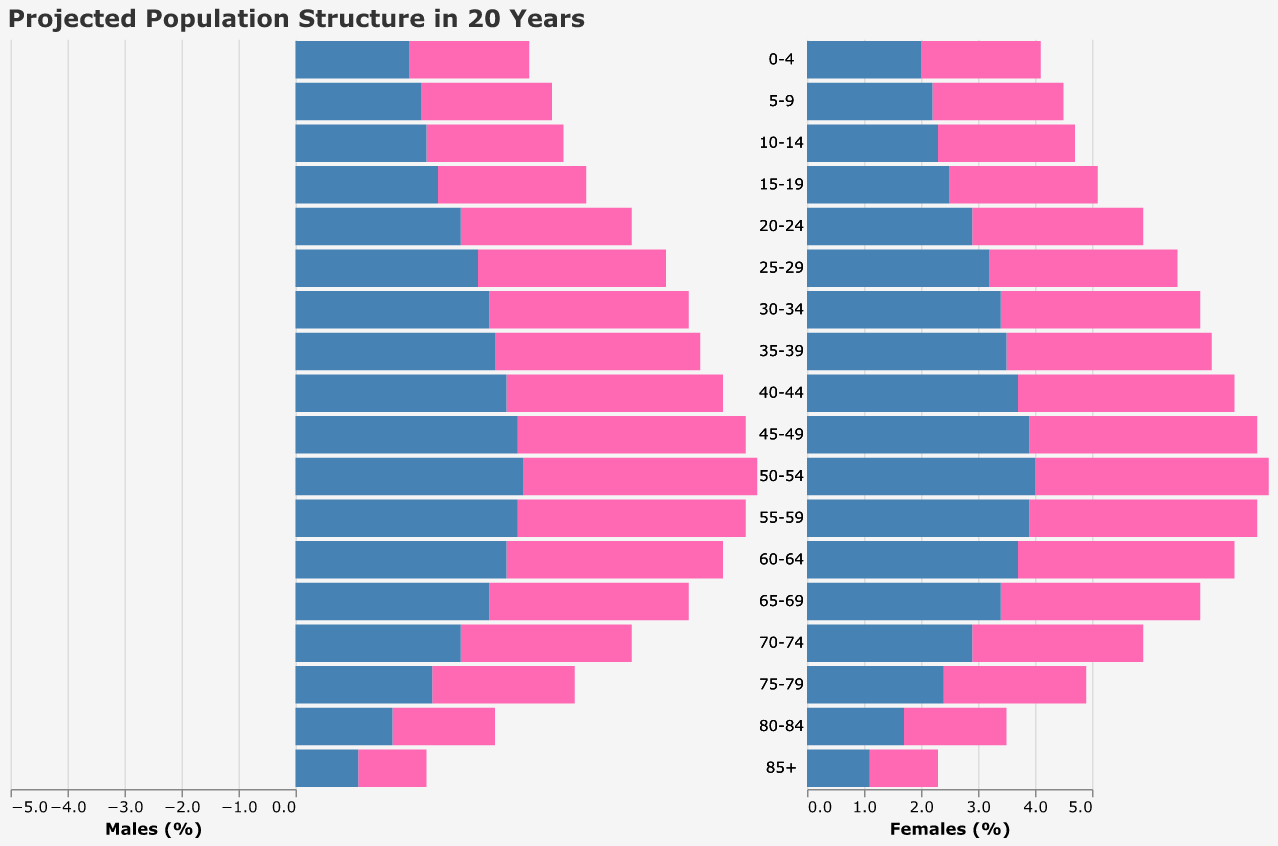Is the population of females in the 85+ age group higher or lower than that of males? By looking at the bar lengths for the 85+ age group, we see that the female bar extends to 1.1%, while the male bar extends to -1.2%. The negative sign on the males' side indicates the population percentage. We compare the absolute values, and -1.2% (males) is slightly higher than 1.1% (females).
Answer: Lower Which age group has the highest population percentage for males? We look at the male side of the population pyramid and identify the age group with the longest bar. The age group 50-54 has the longest bar extending to -4.1%.
Answer: 50-54 What is the difference in population percentage between males and females in the age group 25-29? The population percentage for females in the 25-29 age group is 3.2%, and for males, it is -3.3%. We find the absolute difference: 3.3% - 3.2% = 0.1%.
Answer: 0.1% Has the population percentage for females aged 15-19 increased or decreased compared to the previous age group? Comparing the lengths of the bars for the 10-14 and 15-19 female age groups, the bar length for 15-19 (2.5%) is longer than that for 10-14 (2.3%), indicating an increase.
Answer: Increased What trend can be observed in the population percentage of both genders as age increases? As we move up the age groups in the pyramid, there is a general trend of decreasing population percentages for both males and females, indicating a lower proportion of older individuals compared to younger ones.
Answer: Decreasing In which age group do males and females have the same population percentage? By examining the bars for each age group, the population percentage for males and females in the 55-59 age group is both -3.9% and 3.9% respectively.
Answer: 55-59 What is the combined population percentage of the 20-24 age group for both genders? The percentage for males is -3.0%, and for females, it is 2.9%. Combined, the absolute values sum up to 3.0% + 2.9% = 5.9%.
Answer: 5.9% Which gender has a higher population percentage in the 45-49 age group? Looking at the bars for the 45-49 age group, the female bar extends to 3.9%, while the male bar extends to -4.0%. Comparing absolute values shows 4.0% (males) is higher than 3.9% (females).
Answer: Males 